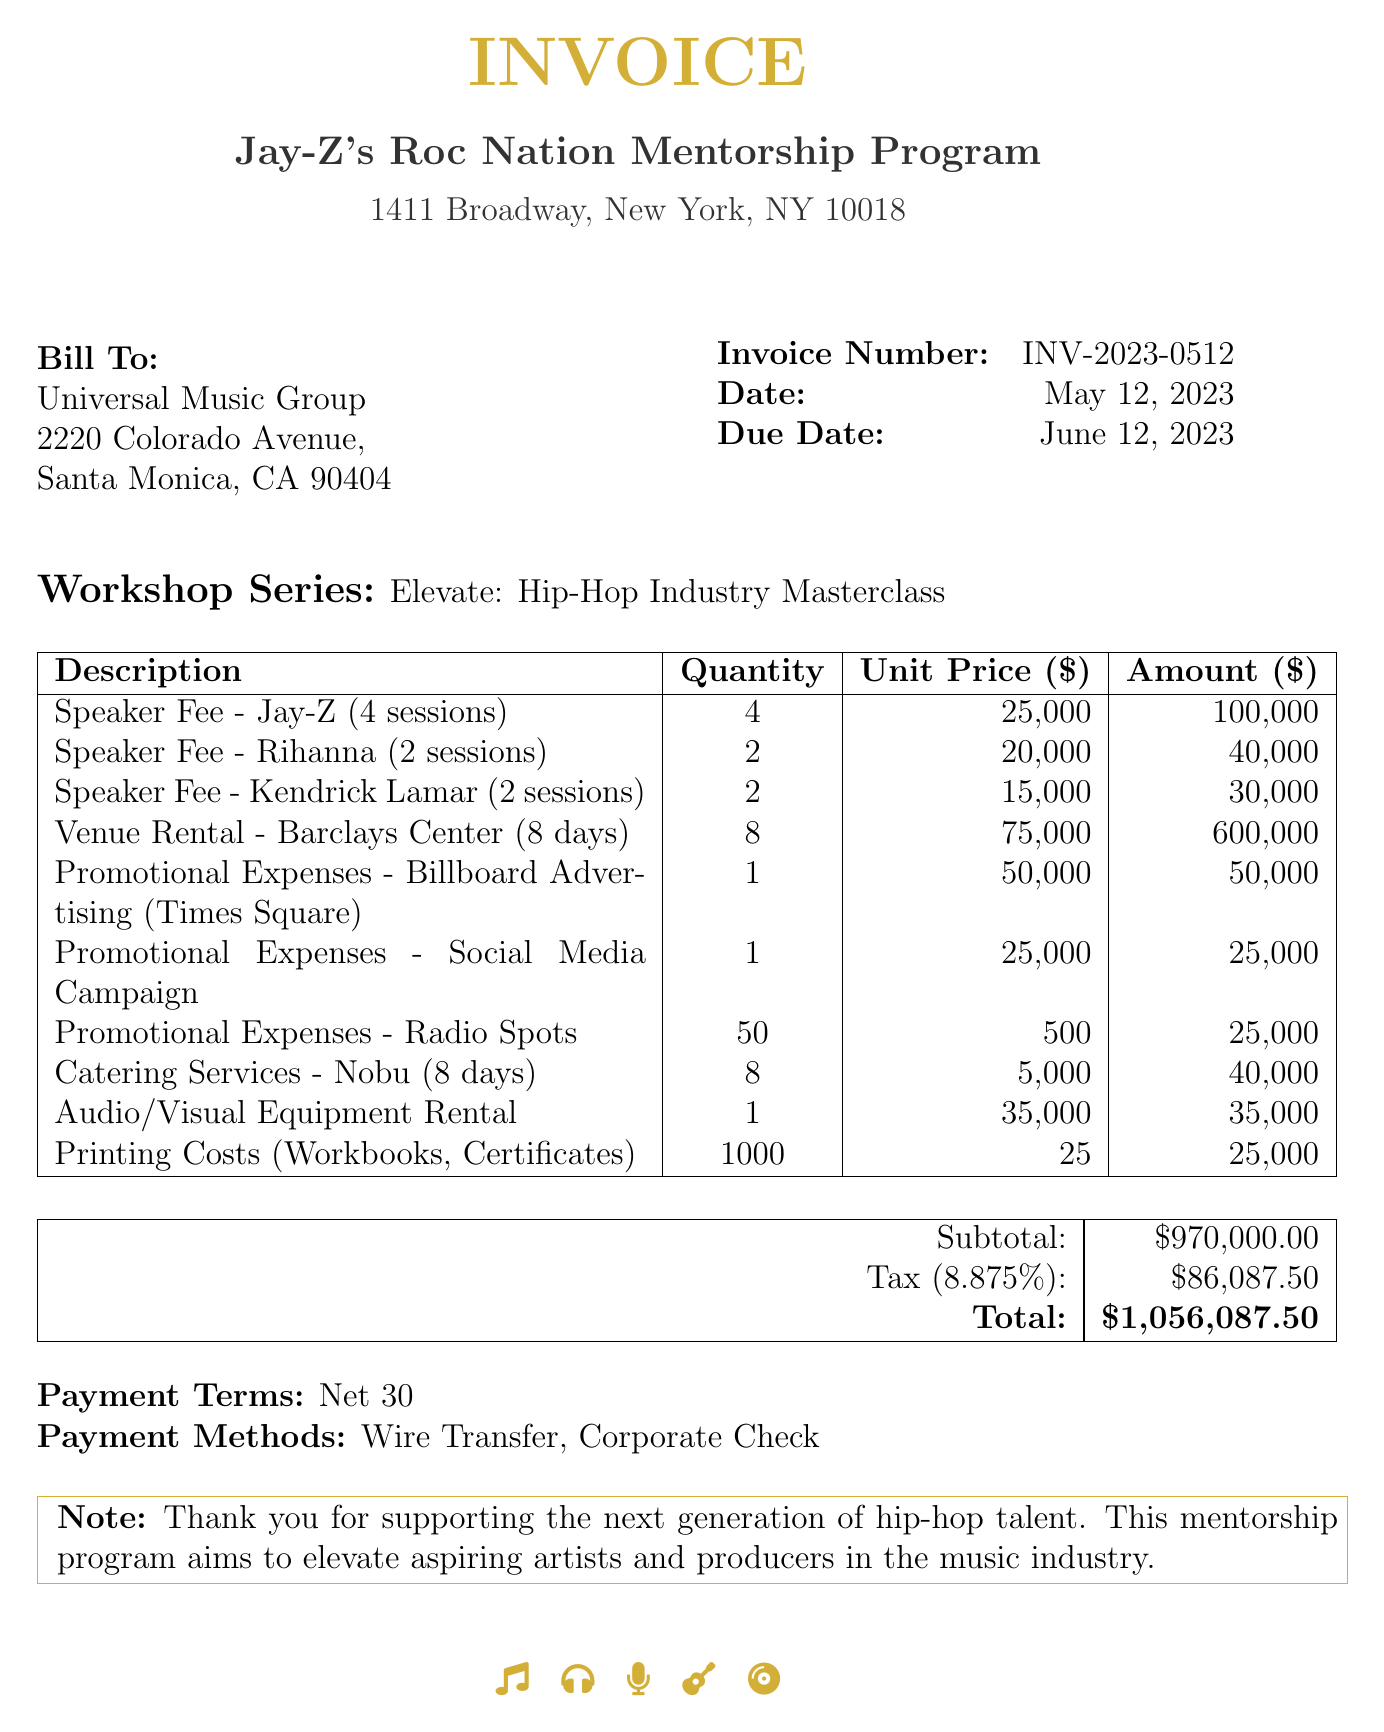what is the invoice number? The invoice number is listed at the top of the document for identification purposes.
Answer: INV-2023-0512 who is the sender of the invoice? The sender of the invoice is specified under "From".
Answer: Jay-Z's Roc Nation Mentorship Program what is the date of the invoice? The date of the invoice is provided to indicate when it was issued.
Answer: May 12, 2023 how many sessions did Jay-Z conduct? The document specifies the number of sessions related to Jay-Z's speaking fee.
Answer: 4 sessions what is the total amount due? The total amount due is calculated from the subtotal and tax noted at the end of the document.
Answer: 1,056,087.50 what is the tax rate applied in the invoice? The tax rate is provided to calculate the tax amount on the subtotal.
Answer: 8.875% which venue was rented for the workshop series? The document indicates the venue rented for the event.
Answer: Barclays Center how many promotional expenses items are listed? The document lists several promotional expense items under the workshop series costs.
Answer: 3 items what are the payment methods stated? The document specifies the methods of payment accepted for this invoice.
Answer: Wire Transfer, Corporate Check 